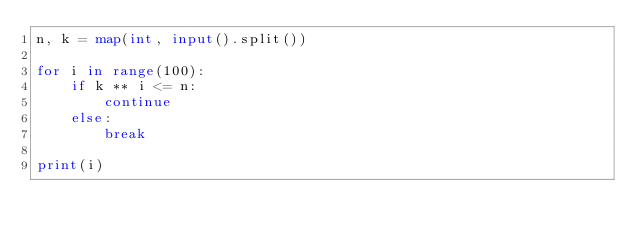<code> <loc_0><loc_0><loc_500><loc_500><_Python_>n, k = map(int, input().split())

for i in range(100):
    if k ** i <= n:
        continue
    else:
        break

print(i)</code> 